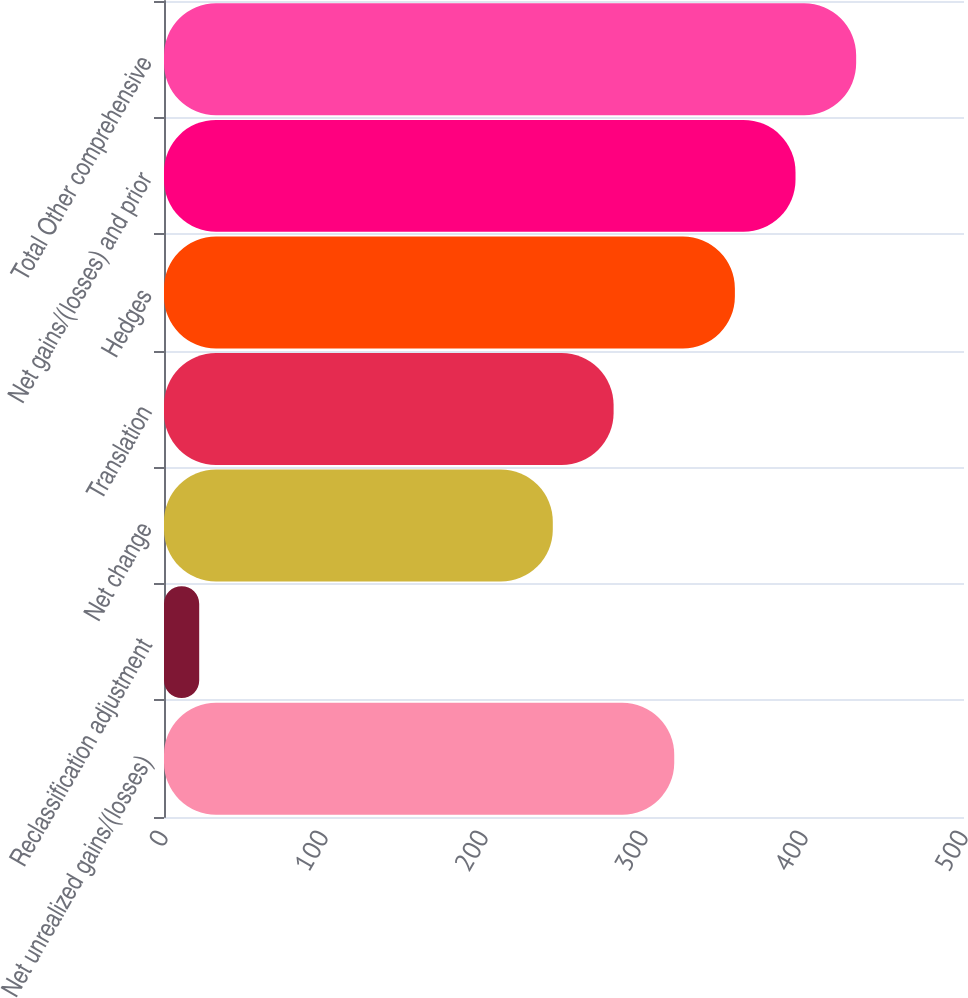Convert chart. <chart><loc_0><loc_0><loc_500><loc_500><bar_chart><fcel>Net unrealized gains/(losses)<fcel>Reclassification adjustment<fcel>Net change<fcel>Translation<fcel>Hedges<fcel>Net gains/(losses) and prior<fcel>Total Other comprehensive<nl><fcel>318.9<fcel>22<fcel>243<fcel>281<fcel>356.8<fcel>394.7<fcel>432.6<nl></chart> 